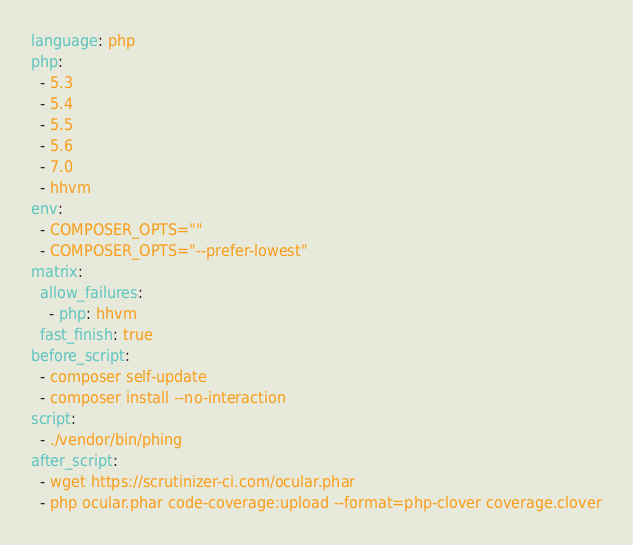Convert code to text. <code><loc_0><loc_0><loc_500><loc_500><_YAML_>language: php
php:
  - 5.3
  - 5.4
  - 5.5
  - 5.6
  - 7.0
  - hhvm
env:
  - COMPOSER_OPTS=""
  - COMPOSER_OPTS="--prefer-lowest"
matrix:
  allow_failures:
    - php: hhvm
  fast_finish: true
before_script:
  - composer self-update
  - composer install --no-interaction
script:
  - ./vendor/bin/phing
after_script:
  - wget https://scrutinizer-ci.com/ocular.phar
  - php ocular.phar code-coverage:upload --format=php-clover coverage.clover
</code> 